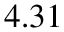<formula> <loc_0><loc_0><loc_500><loc_500>4 . 3 1</formula> 